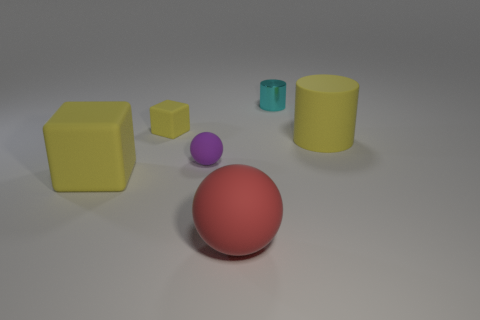Add 2 small cyan cubes. How many objects exist? 8 Subtract all cylinders. How many objects are left? 4 Subtract all cyan cylinders. How many cylinders are left? 1 Subtract all large red rubber things. Subtract all big brown cylinders. How many objects are left? 5 Add 1 big matte balls. How many big matte balls are left? 2 Add 5 rubber objects. How many rubber objects exist? 10 Subtract 0 purple cylinders. How many objects are left? 6 Subtract all gray cubes. Subtract all gray cylinders. How many cubes are left? 2 Subtract all brown blocks. How many green balls are left? 0 